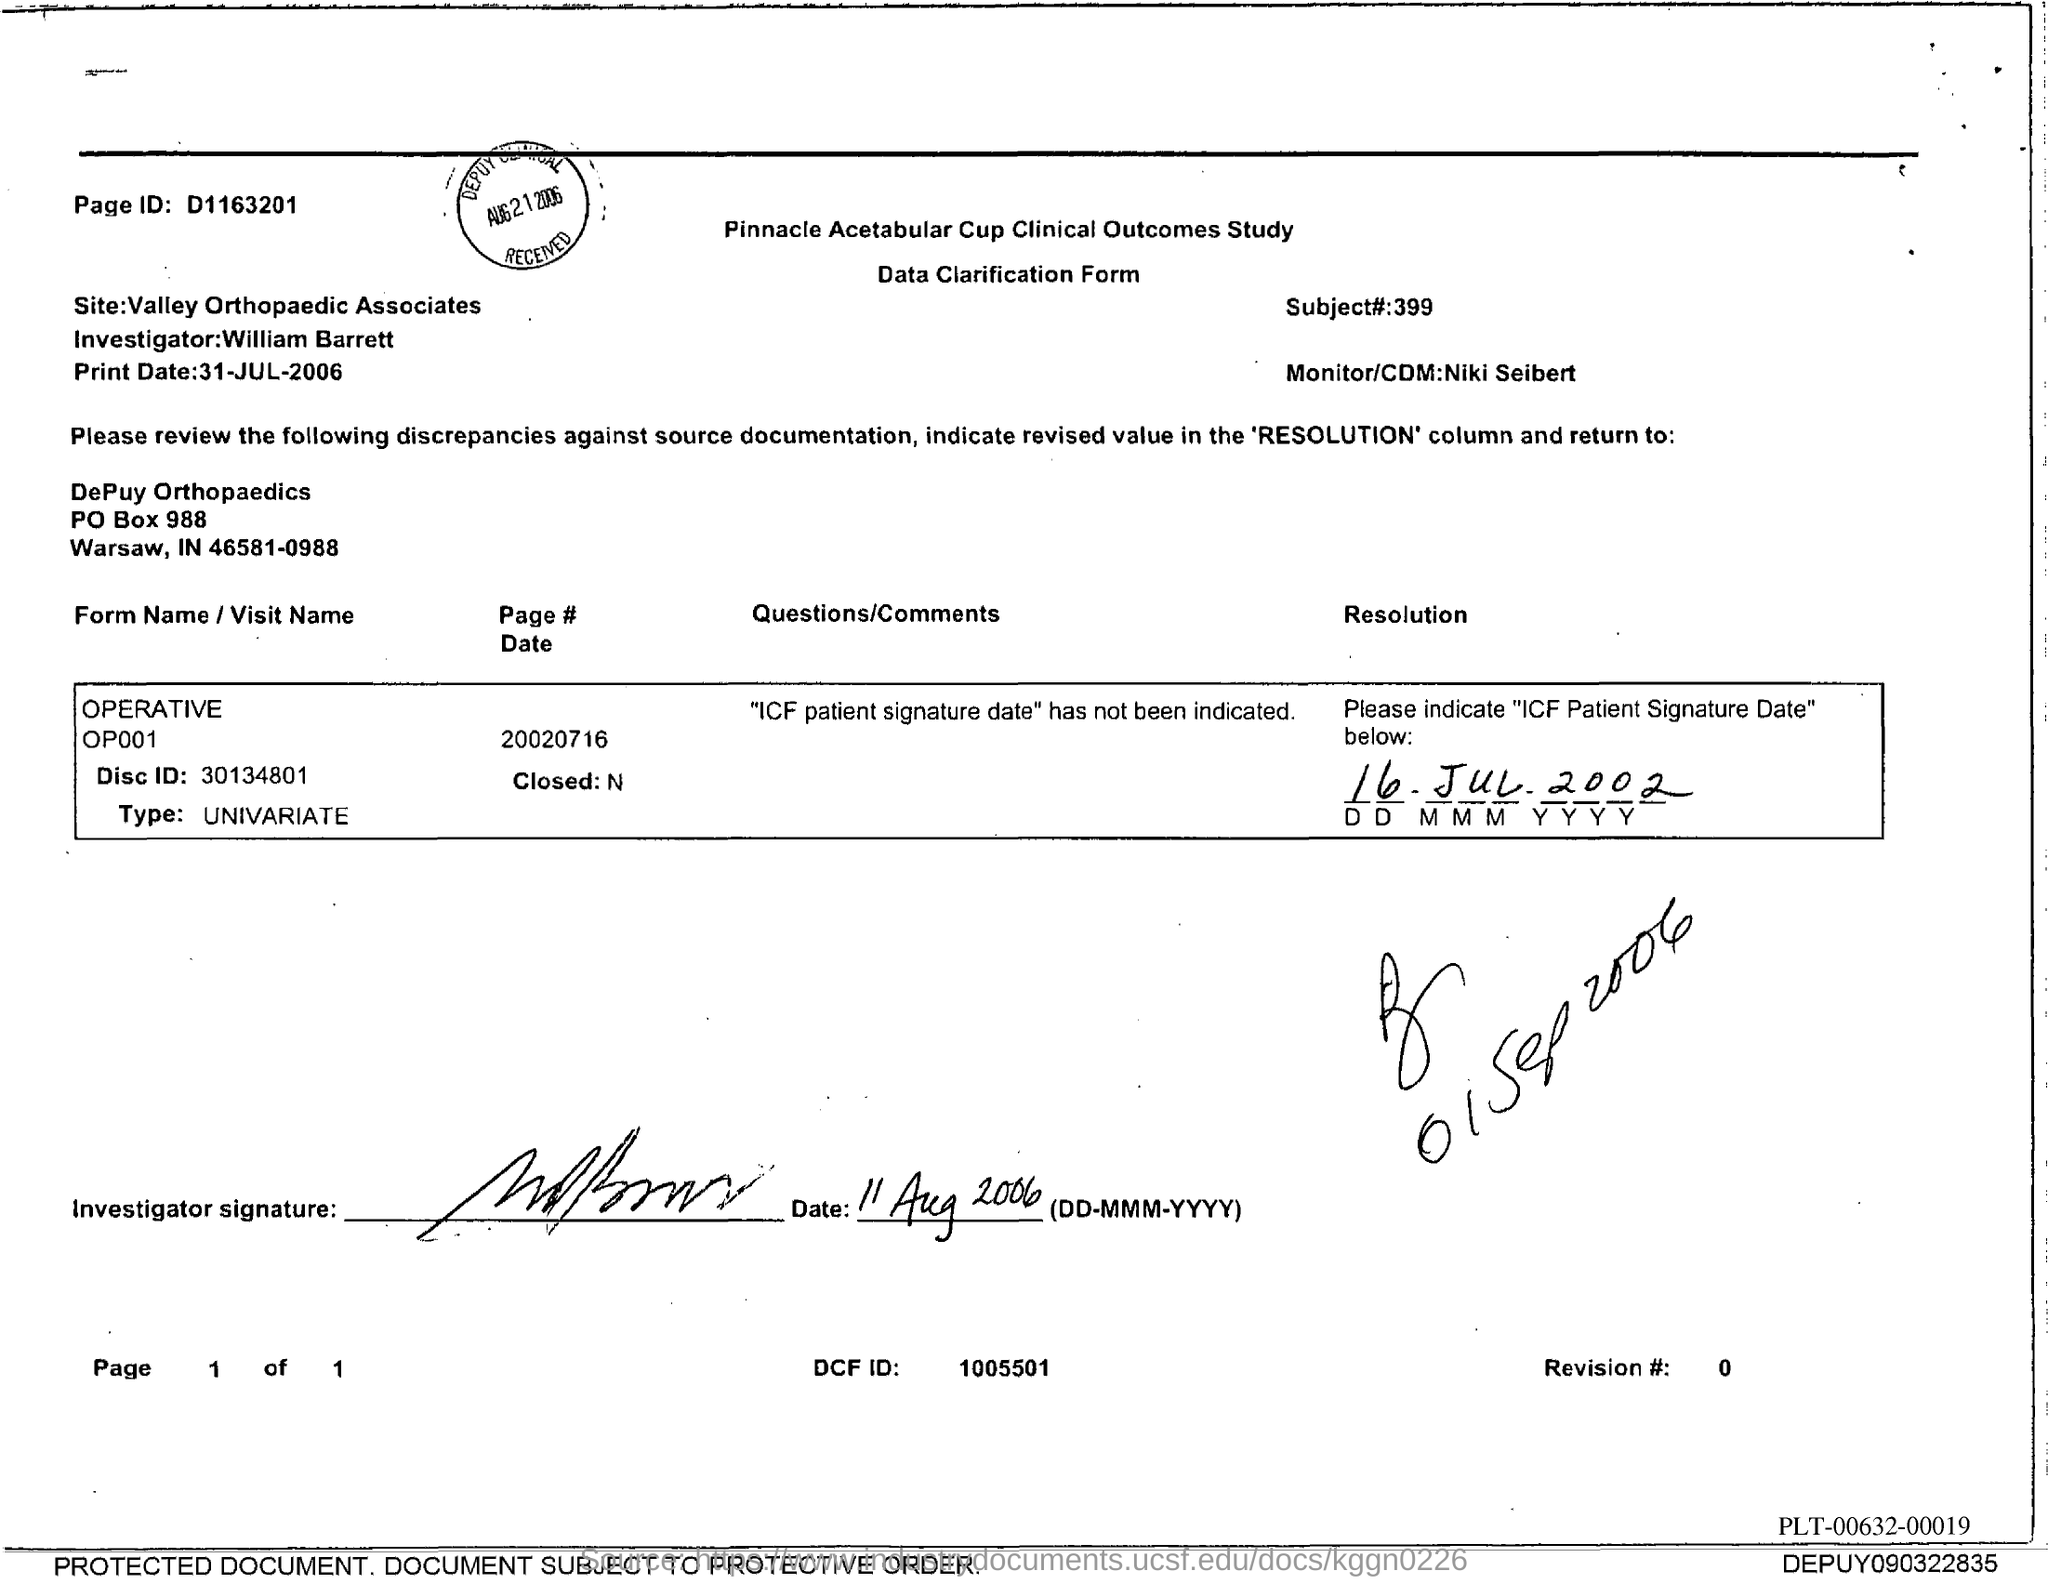Give some essential details in this illustration. William Barrett is the investigator mentioned in the form. The DCF ID mentioned in the form is 1005501. The Page ID mentioned in the form is D1163201. The name of the Monitor/CDM mentioned in the form is Niki Seibert. The subject number mentioned in the form is 399.. 